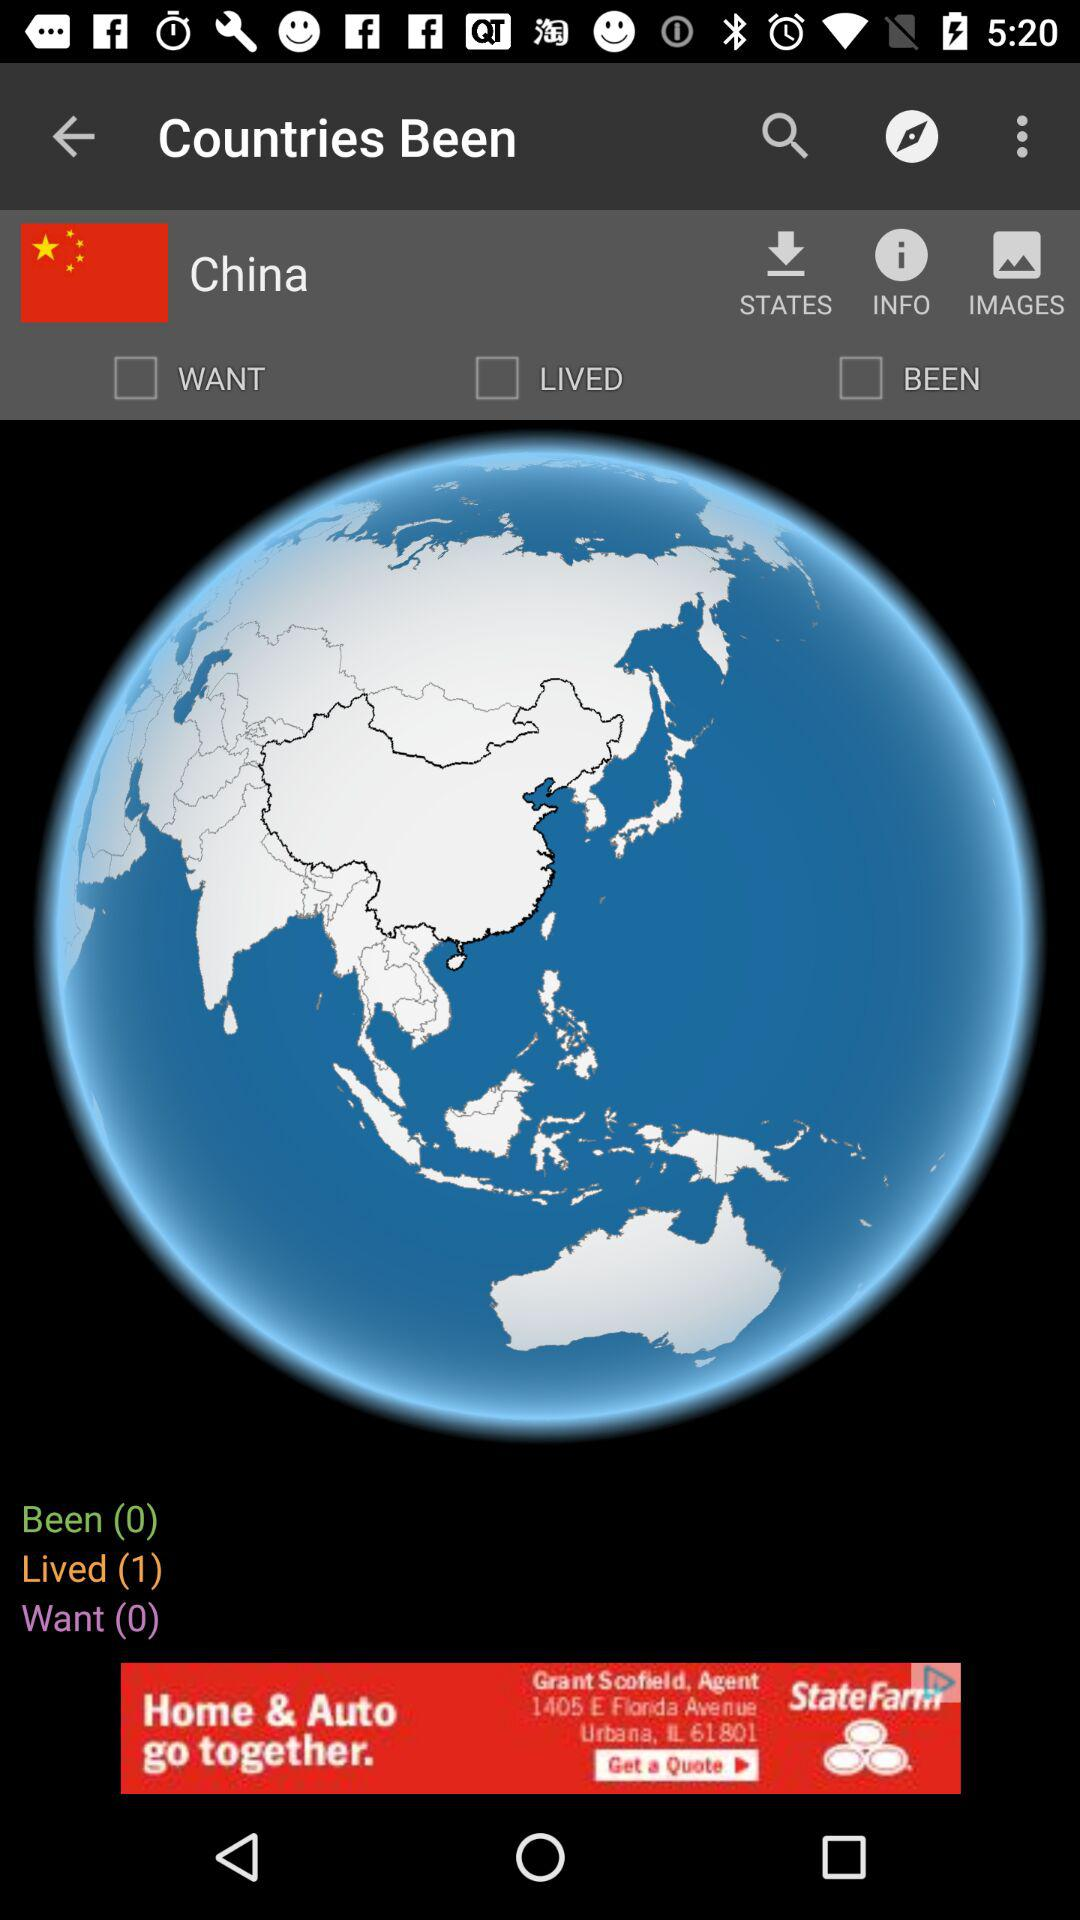What is the country? The country is China. 